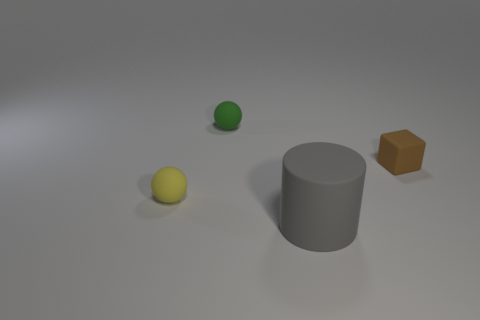There is a matte cylinder; is its size the same as the rubber ball that is right of the yellow sphere?
Provide a short and direct response. No. There is a rubber thing on the left side of the small matte ball that is behind the tiny thing that is to the left of the tiny green matte ball; what is its size?
Ensure brevity in your answer.  Small. What number of rubber objects are either green things or yellow spheres?
Keep it short and to the point. 2. There is a tiny ball that is in front of the tiny green thing; what is its color?
Your answer should be very brief. Yellow. What is the shape of the green object that is the same size as the cube?
Provide a short and direct response. Sphere. Do the small block and the rubber object on the left side of the green object have the same color?
Offer a terse response. No. How many things are either tiny rubber things that are to the right of the yellow rubber object or tiny rubber things that are to the right of the tiny green matte sphere?
Give a very brief answer. 2. There is a brown cube that is the same size as the yellow rubber object; what is its material?
Offer a very short reply. Rubber. What number of other objects are the same material as the block?
Provide a succinct answer. 3. There is a rubber thing in front of the tiny yellow object; does it have the same shape as the matte object behind the brown matte block?
Give a very brief answer. No. 